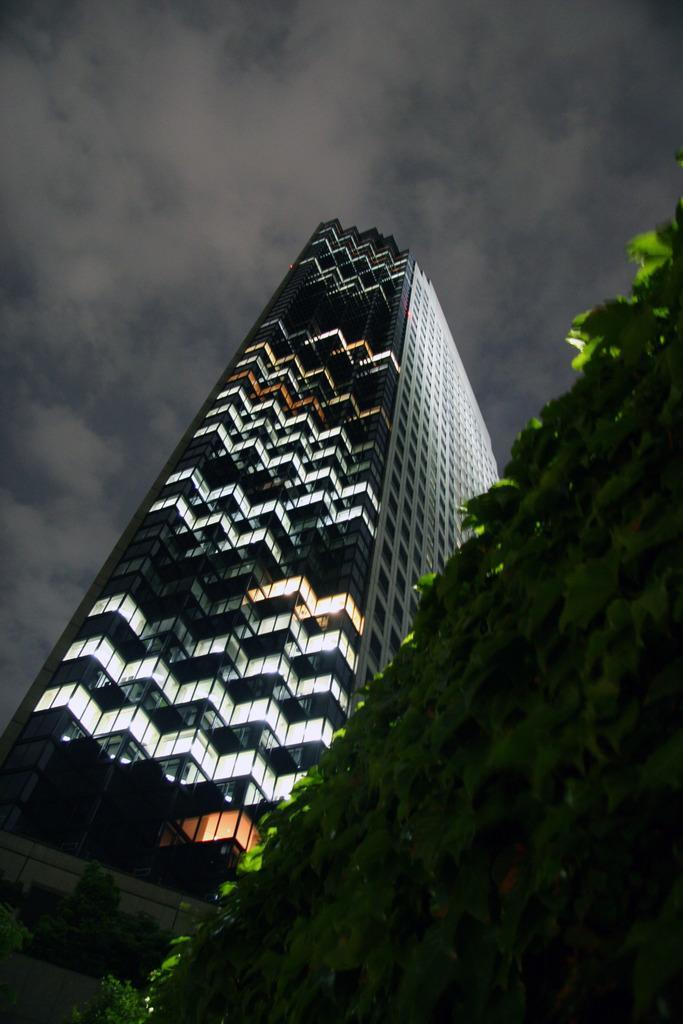How would you summarize this image in a sentence or two? In this image there is a tree, in the background there is a big building and a cloudy sky. 